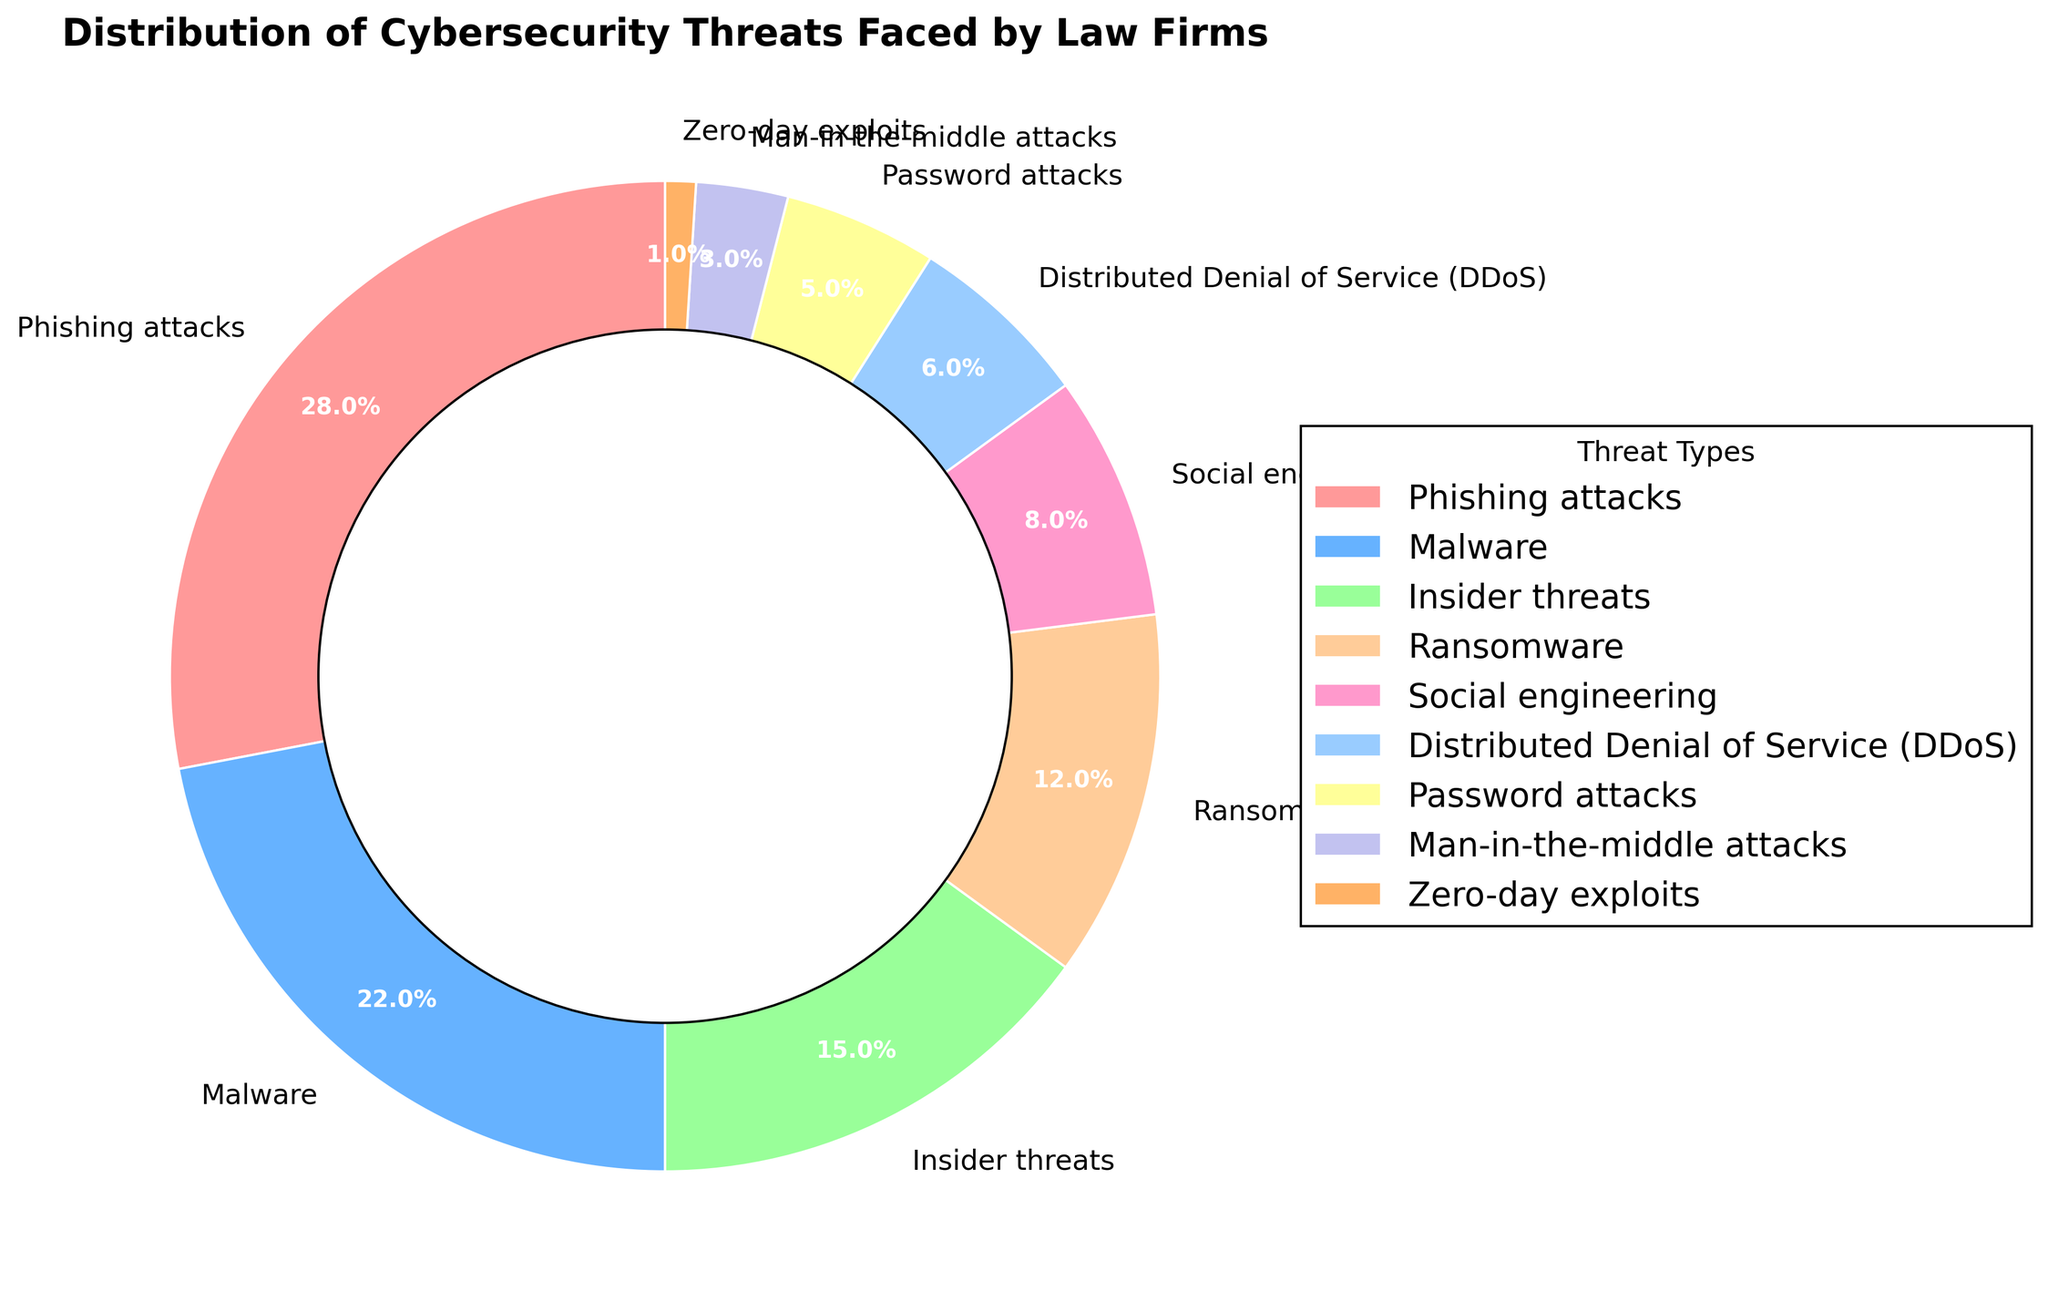What is the most common cybersecurity threat faced by law firms? Looking at the pie chart, "Phishing attacks" has the largest slice of the pie with 28%.
Answer: Phishing attacks Which is more prevalent, Malware or Insider threats? According to the pie chart, Malware is at 22% while Insider threats are at 15%, making Malware more prevalent.
Answer: Malware How much more common are Phishing attacks compared to Ransomware? Phishing attacks are 28% and Ransomware is 12%. The difference is 28% - 12% = 16%.
Answer: 16% What percentage of threats is due to Social engineering and DDoS combined? Add the percentages for Social engineering (8%) and DDoS (6%). This gives 8% + 6% = 14%.
Answer: 14% Are Password attacks more or less common than Man-in-the-middle attacks? The pie chart shows that Password attacks are at 5% while Man-in-the-middle attacks are at 3%, indicating Password attacks are more common.
Answer: Password attacks What is the smallest slice in the pie chart? Zero-day exploits is the smallest slice, representing 1% of the threats.
Answer: Zero-day exploits Which three threat types combined make up exactly half of the total threats? Phishing attacks (28%), Malware (22%) and Insider threats (15%) are the top three threats. Adding them: 28% + 22% + 15% = 65%, which is not 50%. Next, consider Phishing attacks (28%), Malware (22%), and Ransomware (12%): 28% + 22% + 12% = 62%. Different set: Phishing attacks (28%), Malware (22%), and Social engineering (8%): 28% + 22% + 8% = 58%. Adding Phishing attacks (28%), Malware (22%), and DDoS (6%): 28% + 22% + 6% = 56%. Finally, the correct set: Malware (22%), Insider threats (15%) and Ransomware (12%) make 22% + 15% + 12% = 49%, very close but not exact. No exact half found; closest is 49%.
Answer: No exact match; closest is Malware, Insider threats, and Ransomware at 49% What proportion of threats is shown by red in the pie chart? Red represents "Phishing attacks" which constitutes 28% of the total threats.
Answer: 28% How much do the combined percentages of the least represented three threats add up to? The three least represented threats are Zero-day exploits (1%), Man-in-the-middle attacks (3%), and Password attacks (5%). Adding them: 1% + 3% + 5% = 9%.
Answer: 9% What are the two second least common threats? According to the chart, DDoS (6%) and Password attacks (5%) are the second least common, following Zero-day exploits.
Answer: DDoS and Password attacks 